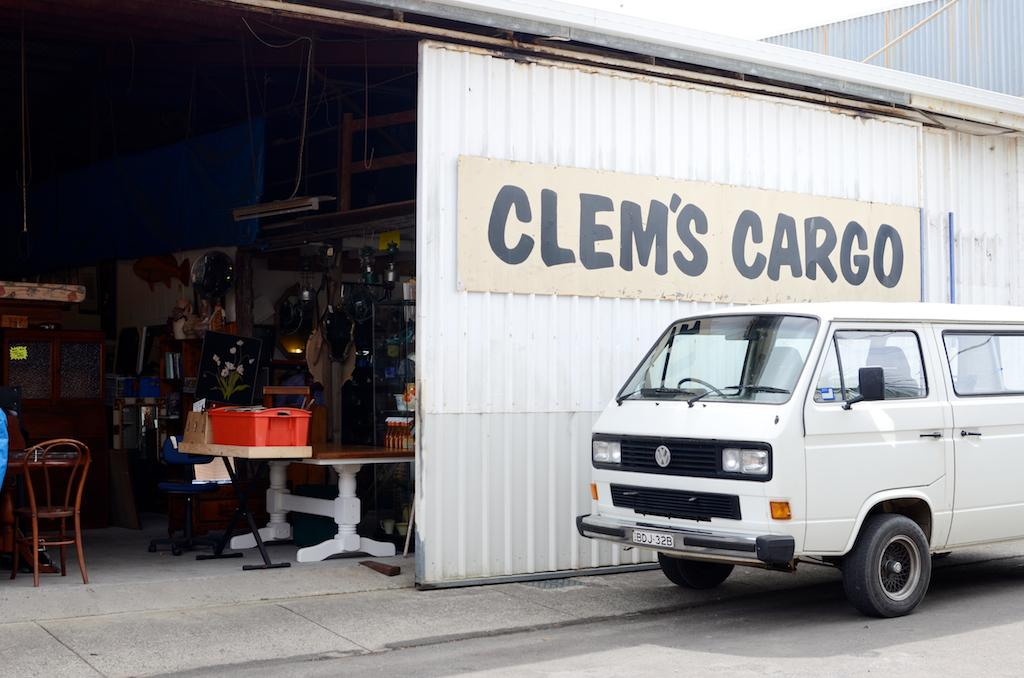What type of structure is present in the image? There is a shed in the image. What is inside the shed? The shed contains groceries. What type of vehicle is parked outside the shed? There is a van parked outside the shed. Where is the van located in relation to the shed? The van is on the road. What type of government is depicted in the image? There is no depiction of a government in the image; it features a shed, groceries, and a van. How many babies are visible in the image? There are no babies present in the image. Is there a tent visible in the image? There is no tent present in the image. 